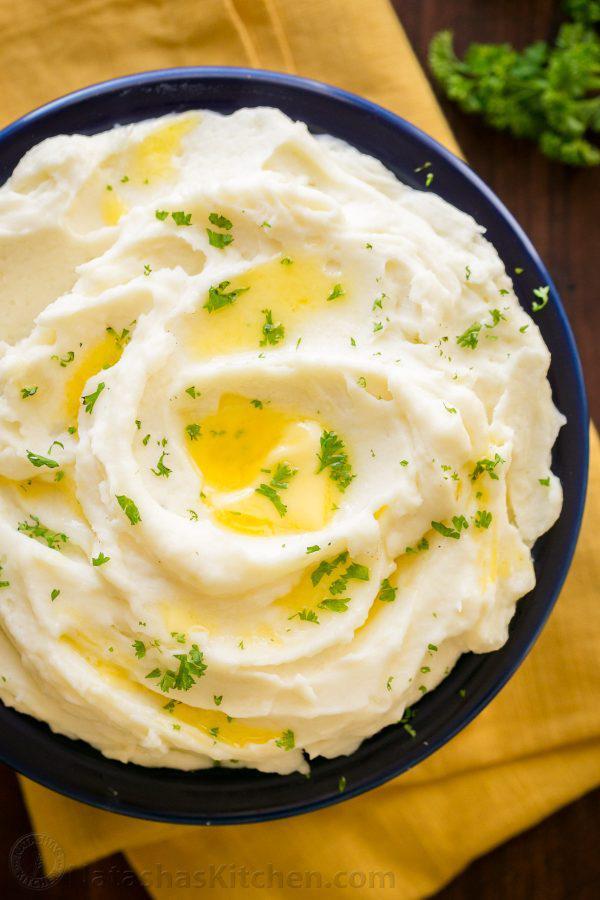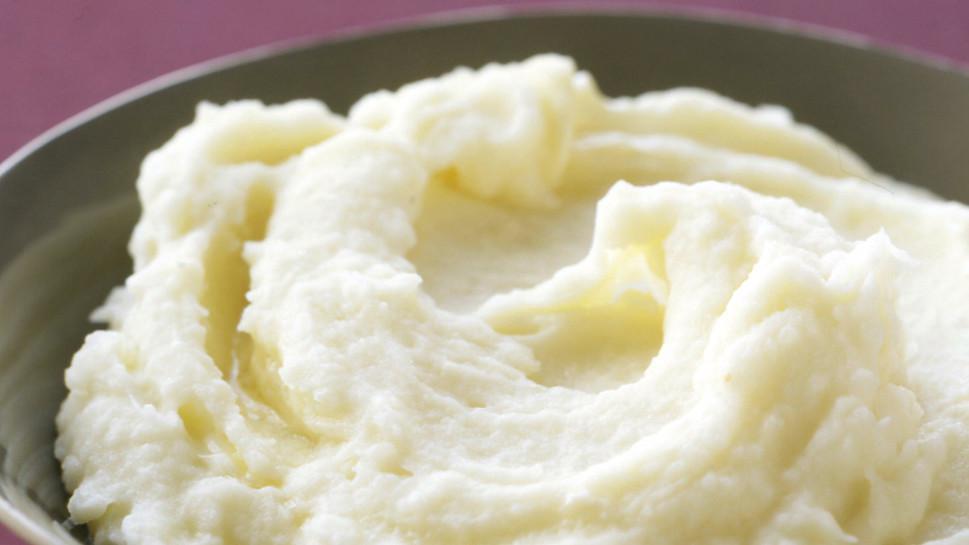The first image is the image on the left, the second image is the image on the right. Evaluate the accuracy of this statement regarding the images: "Oily butter is melting on at least one of the dishes.". Is it true? Answer yes or no. Yes. The first image is the image on the left, the second image is the image on the right. Analyze the images presented: Is the assertion "At least one of the bowls is white." valid? Answer yes or no. No. 